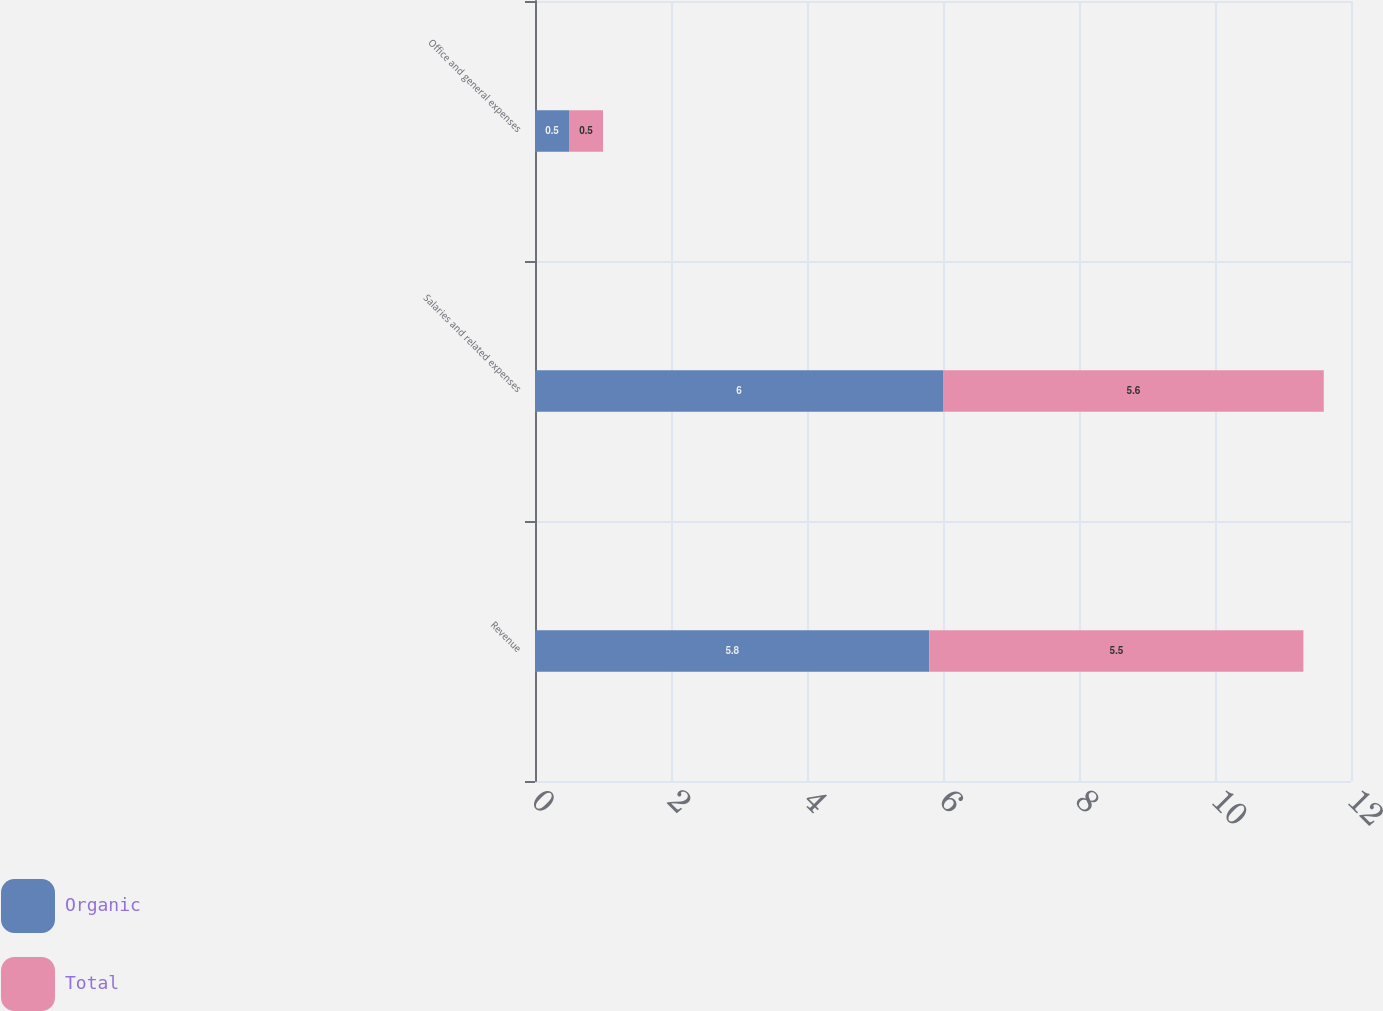<chart> <loc_0><loc_0><loc_500><loc_500><stacked_bar_chart><ecel><fcel>Revenue<fcel>Salaries and related expenses<fcel>Office and general expenses<nl><fcel>Organic<fcel>5.8<fcel>6<fcel>0.5<nl><fcel>Total<fcel>5.5<fcel>5.6<fcel>0.5<nl></chart> 